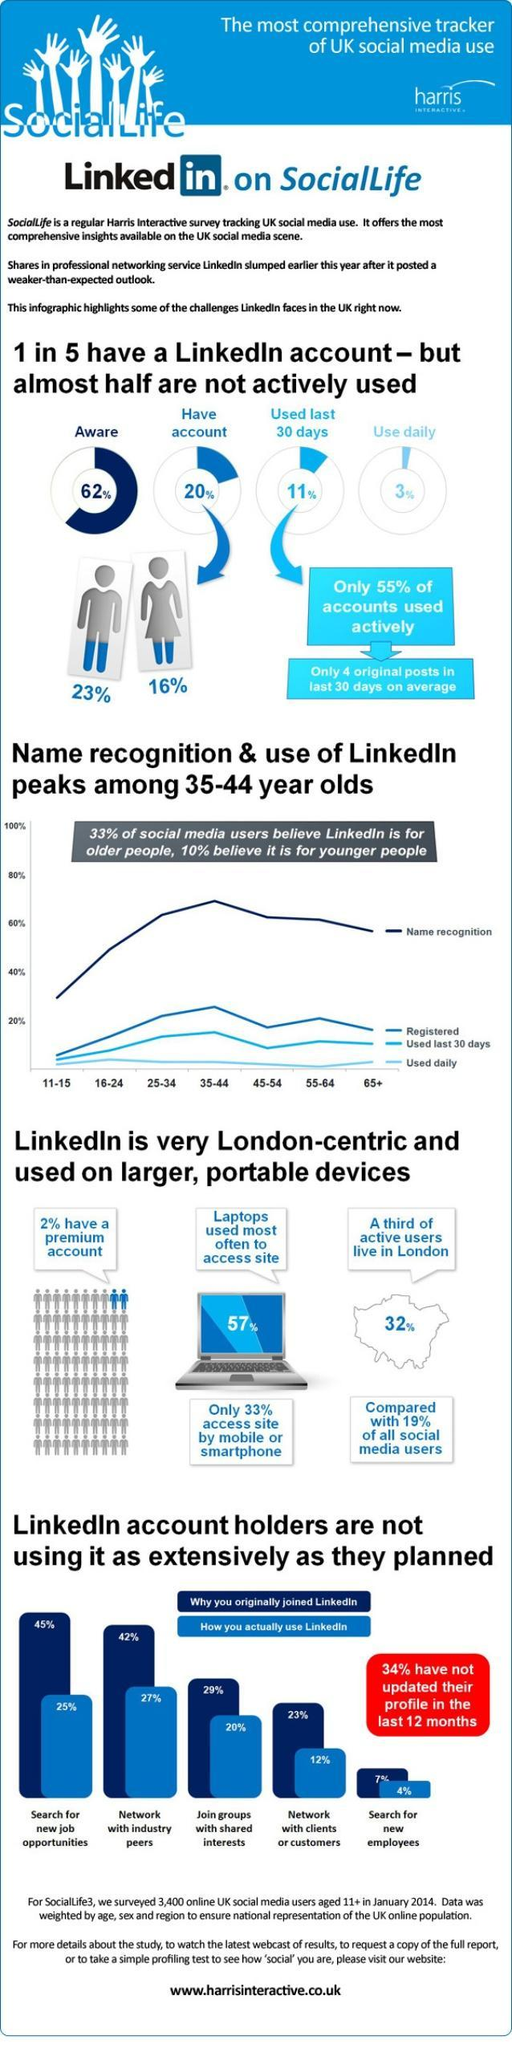What do the highest percentage of users use LinkedIn community for?
Answer the question with a short phrase. Network with industry peers What is the reason for the highest percentage of users to have joined LinkedIn? Search for new job opportunities Which age group of people are the least to use Linkedin daily? 55-64 What is the difference in percentage of men and women who have a Linkedin account? 7% What percentage of user use LinkedIn through laptops? 57% What percentage of people on LinkedIn do not use it on a daily basis? 97% What is the percentage of users from London use LinkedIn regularly? 32% 